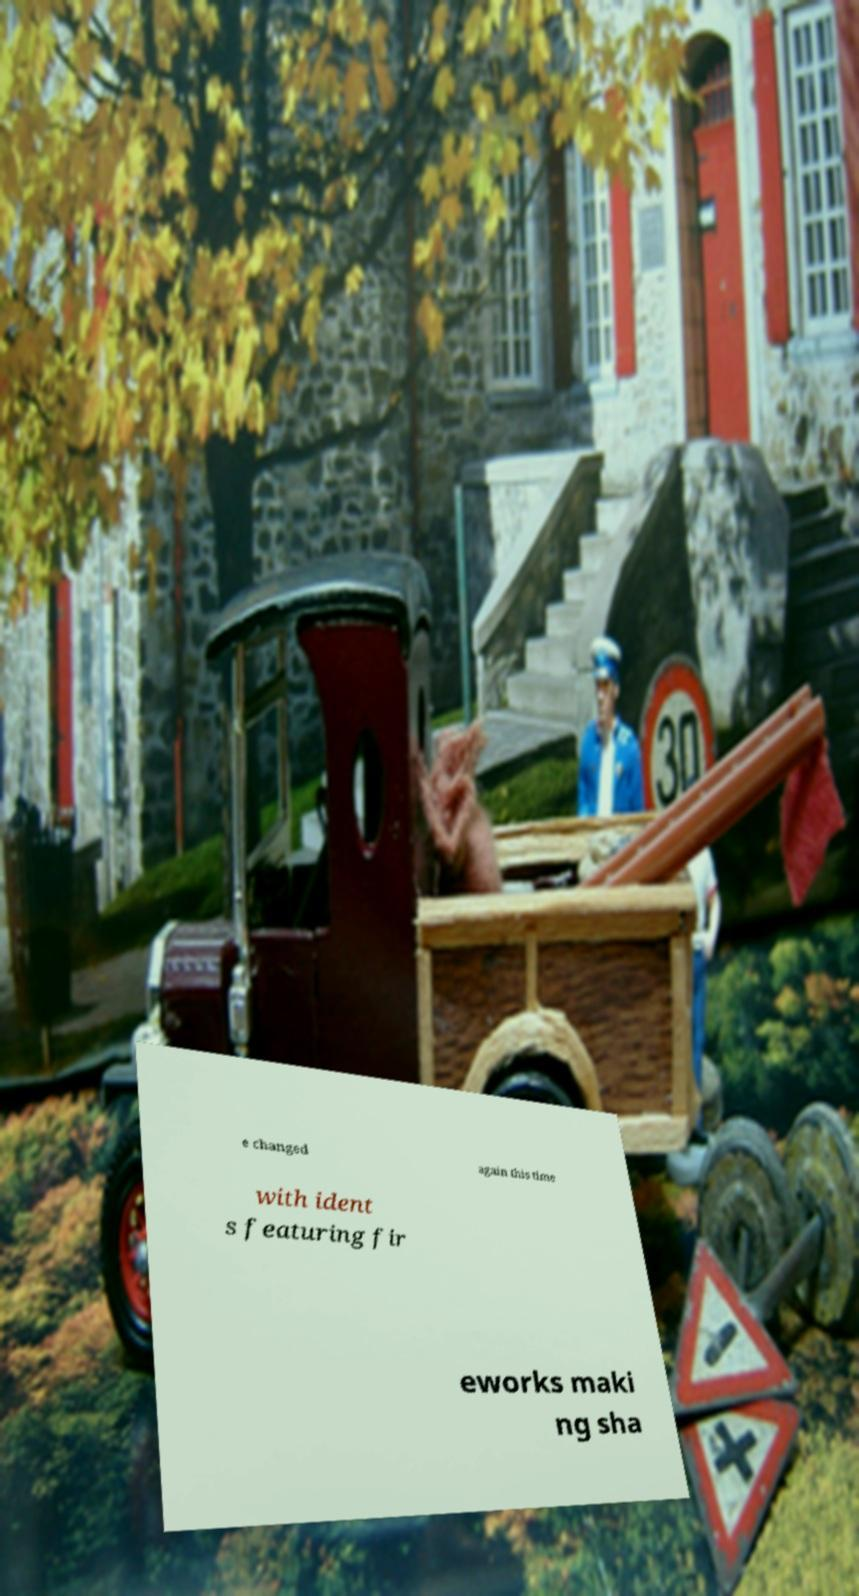I need the written content from this picture converted into text. Can you do that? e changed again this time with ident s featuring fir eworks maki ng sha 